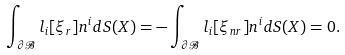<formula> <loc_0><loc_0><loc_500><loc_500>\int _ { \partial \mathcal { B } } l _ { i } [ \xi _ { r } ] n ^ { i } d S ( X ) = - \int _ { \partial \mathcal { B } } l _ { i } [ \xi _ { n r } ] n ^ { i } d S ( X ) = 0 .</formula> 